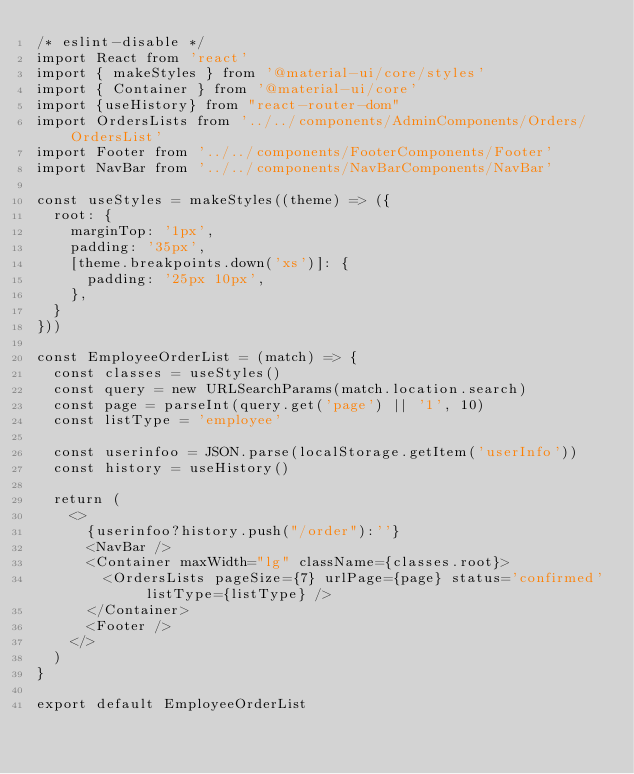Convert code to text. <code><loc_0><loc_0><loc_500><loc_500><_JavaScript_>/* eslint-disable */
import React from 'react'
import { makeStyles } from '@material-ui/core/styles'
import { Container } from '@material-ui/core'
import {useHistory} from "react-router-dom"
import OrdersLists from '../../components/AdminComponents/Orders/OrdersList'
import Footer from '../../components/FooterComponents/Footer'
import NavBar from '../../components/NavBarComponents/NavBar'

const useStyles = makeStyles((theme) => ({
  root: {
    marginTop: '1px',
    padding: '35px',
    [theme.breakpoints.down('xs')]: {
      padding: '25px 10px',
    },
  }
}))

const EmployeeOrderList = (match) => {
  const classes = useStyles()
  const query = new URLSearchParams(match.location.search)
  const page = parseInt(query.get('page') || '1', 10)
  const listType = 'employee'

  const userinfoo = JSON.parse(localStorage.getItem('userInfo'))
  const history = useHistory()

  return (
    <>
      {userinfoo?history.push("/order"):''}
      <NavBar />
      <Container maxWidth="lg" className={classes.root}>
        <OrdersLists pageSize={7} urlPage={page} status='confirmed' listType={listType} />
      </Container>
      <Footer />
    </>
  )
}

export default EmployeeOrderList</code> 